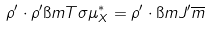<formula> <loc_0><loc_0><loc_500><loc_500>\rho ^ { \prime } \cdot \rho ^ { \prime } \i m { T \sigma } \mu ^ { * } _ { X } = \rho ^ { \prime } \cdot \i m { J ^ { \prime } } \overline { m }</formula> 